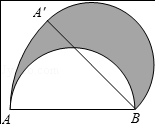How would the figure change if the semicircle were to rotate 90 degrees instead? With a 90 degree rotation of the semicircle, point A would move 90 degrees along the path of the former semicircle's boundary to a new position, creating a quarter-circle. The area of this new shaded region would be one-fourth of the circle's area, which is pi * r^2 * 1/4. Using the radius of 4 units, this equates to 4pi square units. 